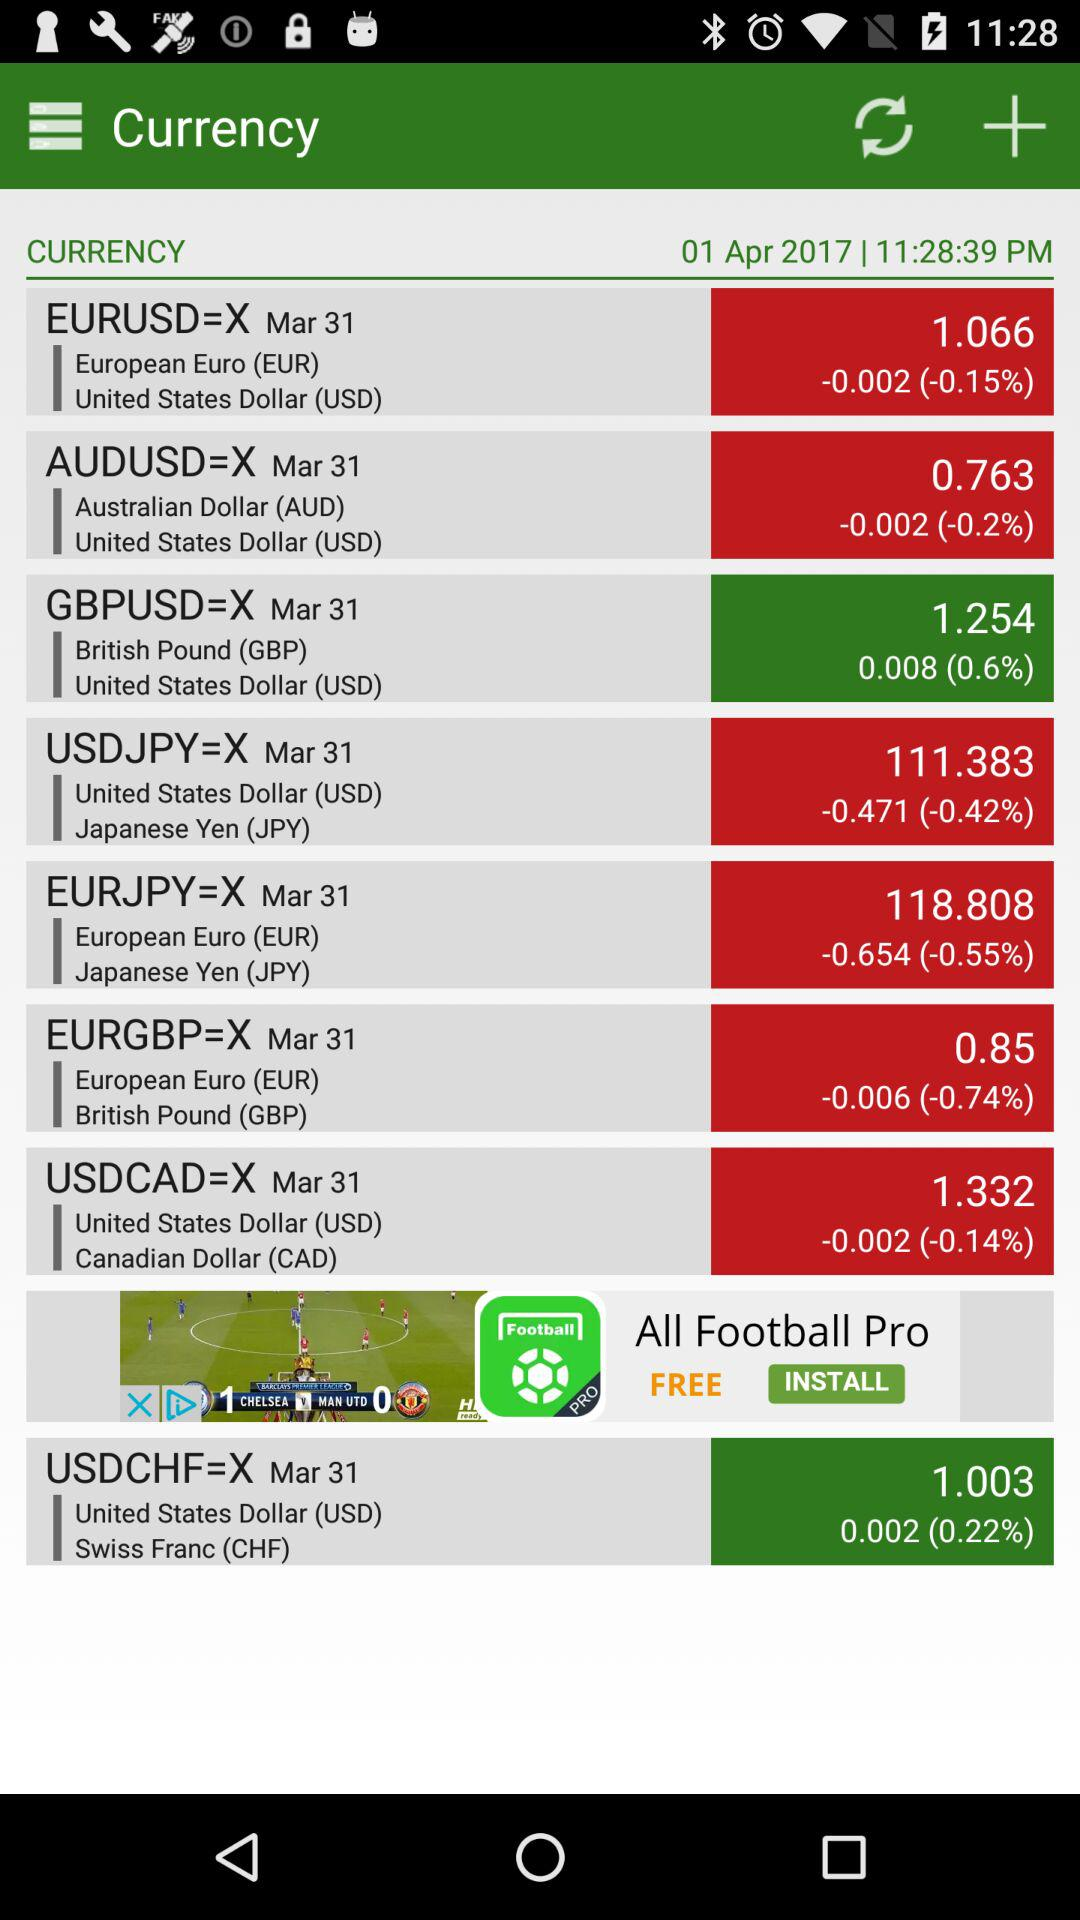What is the percentage change in the EURUSD pair since the last update?
Answer the question using a single word or phrase. -0.15% 